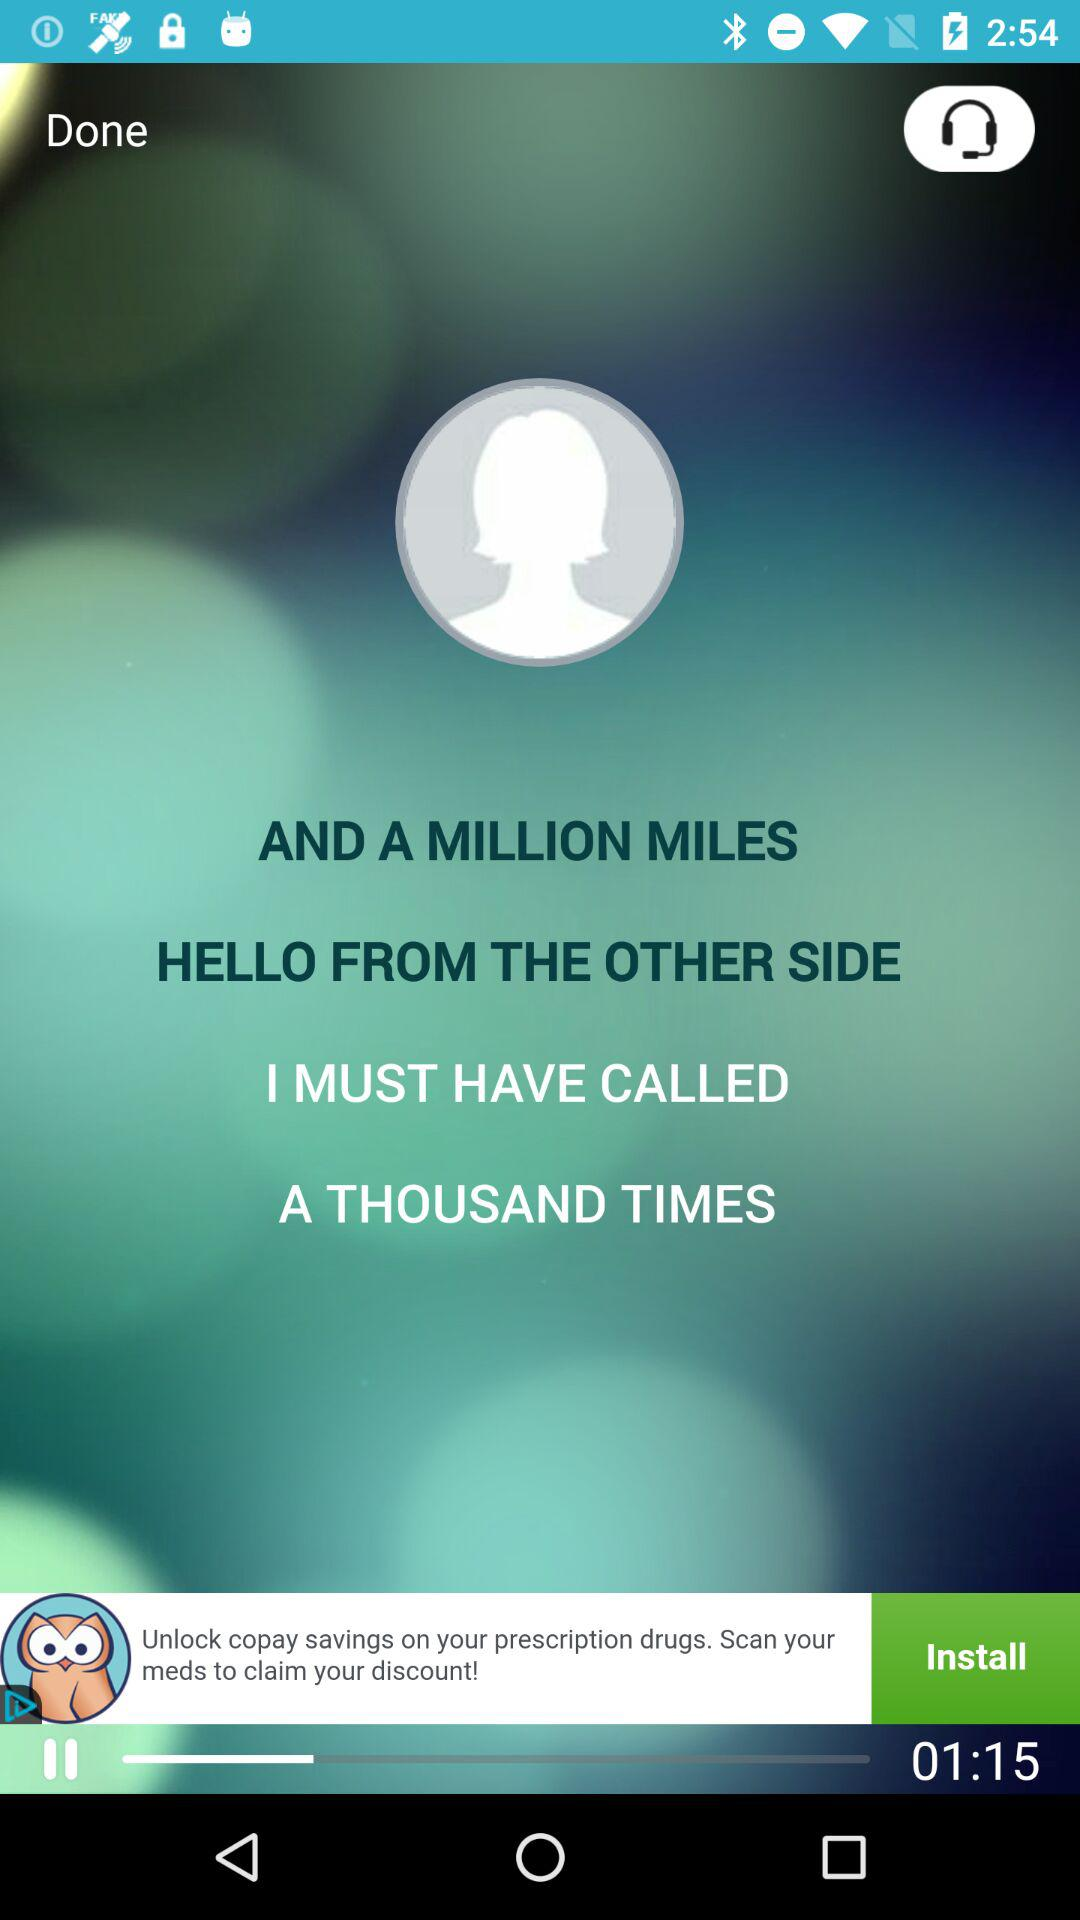How many more seconds are in the song length '01:15' than in the song length '01:00'?
Answer the question using a single word or phrase. 15 